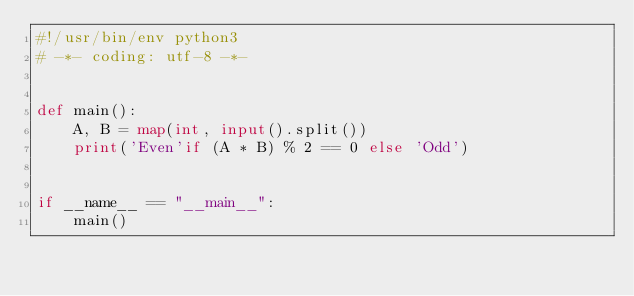<code> <loc_0><loc_0><loc_500><loc_500><_Python_>#!/usr/bin/env python3
# -*- coding: utf-8 -*-


def main():
    A, B = map(int, input().split())
    print('Even'if (A * B) % 2 == 0 else 'Odd')


if __name__ == "__main__":
    main()
</code> 